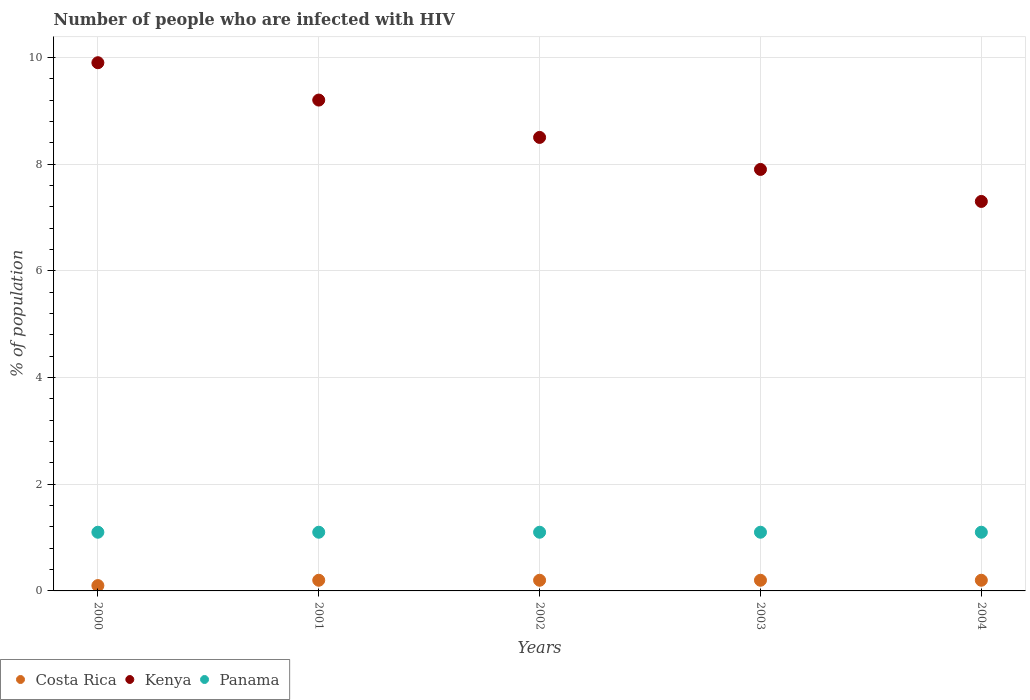How many different coloured dotlines are there?
Make the answer very short. 3. Across all years, what is the maximum percentage of HIV infected population in in Kenya?
Your answer should be very brief. 9.9. Across all years, what is the minimum percentage of HIV infected population in in Costa Rica?
Your answer should be compact. 0.1. In which year was the percentage of HIV infected population in in Panama minimum?
Offer a terse response. 2000. What is the difference between the percentage of HIV infected population in in Costa Rica in 2000 and that in 2004?
Your response must be concise. -0.1. What is the average percentage of HIV infected population in in Costa Rica per year?
Your response must be concise. 0.18. In the year 2003, what is the difference between the percentage of HIV infected population in in Costa Rica and percentage of HIV infected population in in Kenya?
Offer a terse response. -7.7. In how many years, is the percentage of HIV infected population in in Kenya greater than 0.8 %?
Your answer should be very brief. 5. What is the ratio of the percentage of HIV infected population in in Panama in 2000 to that in 2001?
Your response must be concise. 1. Is the difference between the percentage of HIV infected population in in Costa Rica in 2002 and 2004 greater than the difference between the percentage of HIV infected population in in Kenya in 2002 and 2004?
Your answer should be compact. No. What is the difference between the highest and the lowest percentage of HIV infected population in in Kenya?
Offer a terse response. 2.6. In how many years, is the percentage of HIV infected population in in Kenya greater than the average percentage of HIV infected population in in Kenya taken over all years?
Your answer should be compact. 2. Is the sum of the percentage of HIV infected population in in Panama in 2000 and 2003 greater than the maximum percentage of HIV infected population in in Costa Rica across all years?
Offer a terse response. Yes. Does the percentage of HIV infected population in in Costa Rica monotonically increase over the years?
Offer a very short reply. No. Is the percentage of HIV infected population in in Panama strictly less than the percentage of HIV infected population in in Costa Rica over the years?
Your response must be concise. No. Where does the legend appear in the graph?
Give a very brief answer. Bottom left. How many legend labels are there?
Your answer should be very brief. 3. What is the title of the graph?
Your answer should be very brief. Number of people who are infected with HIV. What is the label or title of the X-axis?
Your answer should be compact. Years. What is the label or title of the Y-axis?
Ensure brevity in your answer.  % of population. What is the % of population in Costa Rica in 2000?
Your response must be concise. 0.1. What is the % of population in Panama in 2000?
Your answer should be compact. 1.1. What is the % of population in Costa Rica in 2001?
Your answer should be very brief. 0.2. What is the % of population of Panama in 2001?
Give a very brief answer. 1.1. What is the % of population of Kenya in 2002?
Make the answer very short. 8.5. What is the % of population of Panama in 2002?
Offer a terse response. 1.1. What is the % of population of Costa Rica in 2003?
Provide a short and direct response. 0.2. What is the % of population in Kenya in 2003?
Make the answer very short. 7.9. What is the % of population in Panama in 2003?
Your answer should be very brief. 1.1. What is the % of population in Costa Rica in 2004?
Ensure brevity in your answer.  0.2. What is the % of population in Kenya in 2004?
Ensure brevity in your answer.  7.3. What is the total % of population in Kenya in the graph?
Ensure brevity in your answer.  42.8. What is the total % of population in Panama in the graph?
Provide a short and direct response. 5.5. What is the difference between the % of population of Costa Rica in 2000 and that in 2002?
Provide a short and direct response. -0.1. What is the difference between the % of population in Panama in 2000 and that in 2002?
Give a very brief answer. 0. What is the difference between the % of population in Costa Rica in 2000 and that in 2003?
Your response must be concise. -0.1. What is the difference between the % of population of Kenya in 2000 and that in 2003?
Your answer should be compact. 2. What is the difference between the % of population in Kenya in 2000 and that in 2004?
Ensure brevity in your answer.  2.6. What is the difference between the % of population of Costa Rica in 2001 and that in 2002?
Ensure brevity in your answer.  0. What is the difference between the % of population in Kenya in 2001 and that in 2002?
Your answer should be compact. 0.7. What is the difference between the % of population of Costa Rica in 2001 and that in 2003?
Ensure brevity in your answer.  0. What is the difference between the % of population in Panama in 2001 and that in 2003?
Your answer should be compact. 0. What is the difference between the % of population of Kenya in 2001 and that in 2004?
Ensure brevity in your answer.  1.9. What is the difference between the % of population in Costa Rica in 2002 and that in 2003?
Give a very brief answer. 0. What is the difference between the % of population in Kenya in 2002 and that in 2003?
Your answer should be very brief. 0.6. What is the difference between the % of population of Panama in 2002 and that in 2003?
Provide a short and direct response. 0. What is the difference between the % of population of Kenya in 2002 and that in 2004?
Provide a succinct answer. 1.2. What is the difference between the % of population of Panama in 2002 and that in 2004?
Offer a terse response. 0. What is the difference between the % of population of Kenya in 2003 and that in 2004?
Offer a terse response. 0.6. What is the difference between the % of population of Costa Rica in 2000 and the % of population of Panama in 2001?
Provide a short and direct response. -1. What is the difference between the % of population in Kenya in 2000 and the % of population in Panama in 2001?
Keep it short and to the point. 8.8. What is the difference between the % of population of Costa Rica in 2000 and the % of population of Panama in 2003?
Provide a short and direct response. -1. What is the difference between the % of population of Costa Rica in 2000 and the % of population of Panama in 2004?
Give a very brief answer. -1. What is the difference between the % of population in Kenya in 2000 and the % of population in Panama in 2004?
Provide a short and direct response. 8.8. What is the difference between the % of population of Costa Rica in 2001 and the % of population of Kenya in 2002?
Provide a succinct answer. -8.3. What is the difference between the % of population of Costa Rica in 2001 and the % of population of Panama in 2002?
Make the answer very short. -0.9. What is the difference between the % of population of Kenya in 2001 and the % of population of Panama in 2002?
Offer a very short reply. 8.1. What is the difference between the % of population in Kenya in 2001 and the % of population in Panama in 2003?
Ensure brevity in your answer.  8.1. What is the difference between the % of population in Costa Rica in 2001 and the % of population in Panama in 2004?
Ensure brevity in your answer.  -0.9. What is the difference between the % of population in Kenya in 2001 and the % of population in Panama in 2004?
Keep it short and to the point. 8.1. What is the difference between the % of population in Kenya in 2002 and the % of population in Panama in 2003?
Offer a terse response. 7.4. What is the difference between the % of population in Costa Rica in 2002 and the % of population in Panama in 2004?
Offer a very short reply. -0.9. What is the difference between the % of population of Costa Rica in 2003 and the % of population of Panama in 2004?
Provide a short and direct response. -0.9. What is the average % of population of Costa Rica per year?
Your response must be concise. 0.18. What is the average % of population in Kenya per year?
Offer a terse response. 8.56. What is the average % of population in Panama per year?
Your response must be concise. 1.1. In the year 2000, what is the difference between the % of population of Costa Rica and % of population of Kenya?
Give a very brief answer. -9.8. In the year 2000, what is the difference between the % of population of Costa Rica and % of population of Panama?
Your answer should be compact. -1. In the year 2001, what is the difference between the % of population in Costa Rica and % of population in Kenya?
Your answer should be very brief. -9. In the year 2001, what is the difference between the % of population of Costa Rica and % of population of Panama?
Offer a terse response. -0.9. In the year 2002, what is the difference between the % of population of Costa Rica and % of population of Kenya?
Keep it short and to the point. -8.3. In the year 2002, what is the difference between the % of population of Kenya and % of population of Panama?
Your answer should be very brief. 7.4. In the year 2003, what is the difference between the % of population of Costa Rica and % of population of Kenya?
Ensure brevity in your answer.  -7.7. In the year 2004, what is the difference between the % of population of Costa Rica and % of population of Kenya?
Provide a short and direct response. -7.1. In the year 2004, what is the difference between the % of population of Costa Rica and % of population of Panama?
Offer a terse response. -0.9. In the year 2004, what is the difference between the % of population in Kenya and % of population in Panama?
Your answer should be very brief. 6.2. What is the ratio of the % of population in Costa Rica in 2000 to that in 2001?
Provide a succinct answer. 0.5. What is the ratio of the % of population of Kenya in 2000 to that in 2001?
Your response must be concise. 1.08. What is the ratio of the % of population in Costa Rica in 2000 to that in 2002?
Your answer should be compact. 0.5. What is the ratio of the % of population in Kenya in 2000 to that in 2002?
Your answer should be very brief. 1.16. What is the ratio of the % of population in Panama in 2000 to that in 2002?
Your response must be concise. 1. What is the ratio of the % of population in Costa Rica in 2000 to that in 2003?
Keep it short and to the point. 0.5. What is the ratio of the % of population in Kenya in 2000 to that in 2003?
Ensure brevity in your answer.  1.25. What is the ratio of the % of population of Panama in 2000 to that in 2003?
Your answer should be very brief. 1. What is the ratio of the % of population of Costa Rica in 2000 to that in 2004?
Provide a succinct answer. 0.5. What is the ratio of the % of population of Kenya in 2000 to that in 2004?
Your response must be concise. 1.36. What is the ratio of the % of population in Costa Rica in 2001 to that in 2002?
Provide a succinct answer. 1. What is the ratio of the % of population in Kenya in 2001 to that in 2002?
Give a very brief answer. 1.08. What is the ratio of the % of population in Costa Rica in 2001 to that in 2003?
Offer a very short reply. 1. What is the ratio of the % of population of Kenya in 2001 to that in 2003?
Your response must be concise. 1.16. What is the ratio of the % of population of Kenya in 2001 to that in 2004?
Offer a very short reply. 1.26. What is the ratio of the % of population of Panama in 2001 to that in 2004?
Offer a terse response. 1. What is the ratio of the % of population in Costa Rica in 2002 to that in 2003?
Give a very brief answer. 1. What is the ratio of the % of population of Kenya in 2002 to that in 2003?
Keep it short and to the point. 1.08. What is the ratio of the % of population in Panama in 2002 to that in 2003?
Your response must be concise. 1. What is the ratio of the % of population in Kenya in 2002 to that in 2004?
Offer a very short reply. 1.16. What is the ratio of the % of population of Costa Rica in 2003 to that in 2004?
Offer a terse response. 1. What is the ratio of the % of population in Kenya in 2003 to that in 2004?
Your response must be concise. 1.08. What is the difference between the highest and the second highest % of population of Costa Rica?
Give a very brief answer. 0. What is the difference between the highest and the second highest % of population in Kenya?
Your answer should be very brief. 0.7. What is the difference between the highest and the second highest % of population of Panama?
Offer a very short reply. 0. What is the difference between the highest and the lowest % of population in Costa Rica?
Your answer should be compact. 0.1. What is the difference between the highest and the lowest % of population in Panama?
Provide a succinct answer. 0. 